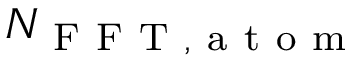<formula> <loc_0><loc_0><loc_500><loc_500>N _ { F F T , a t o m }</formula> 